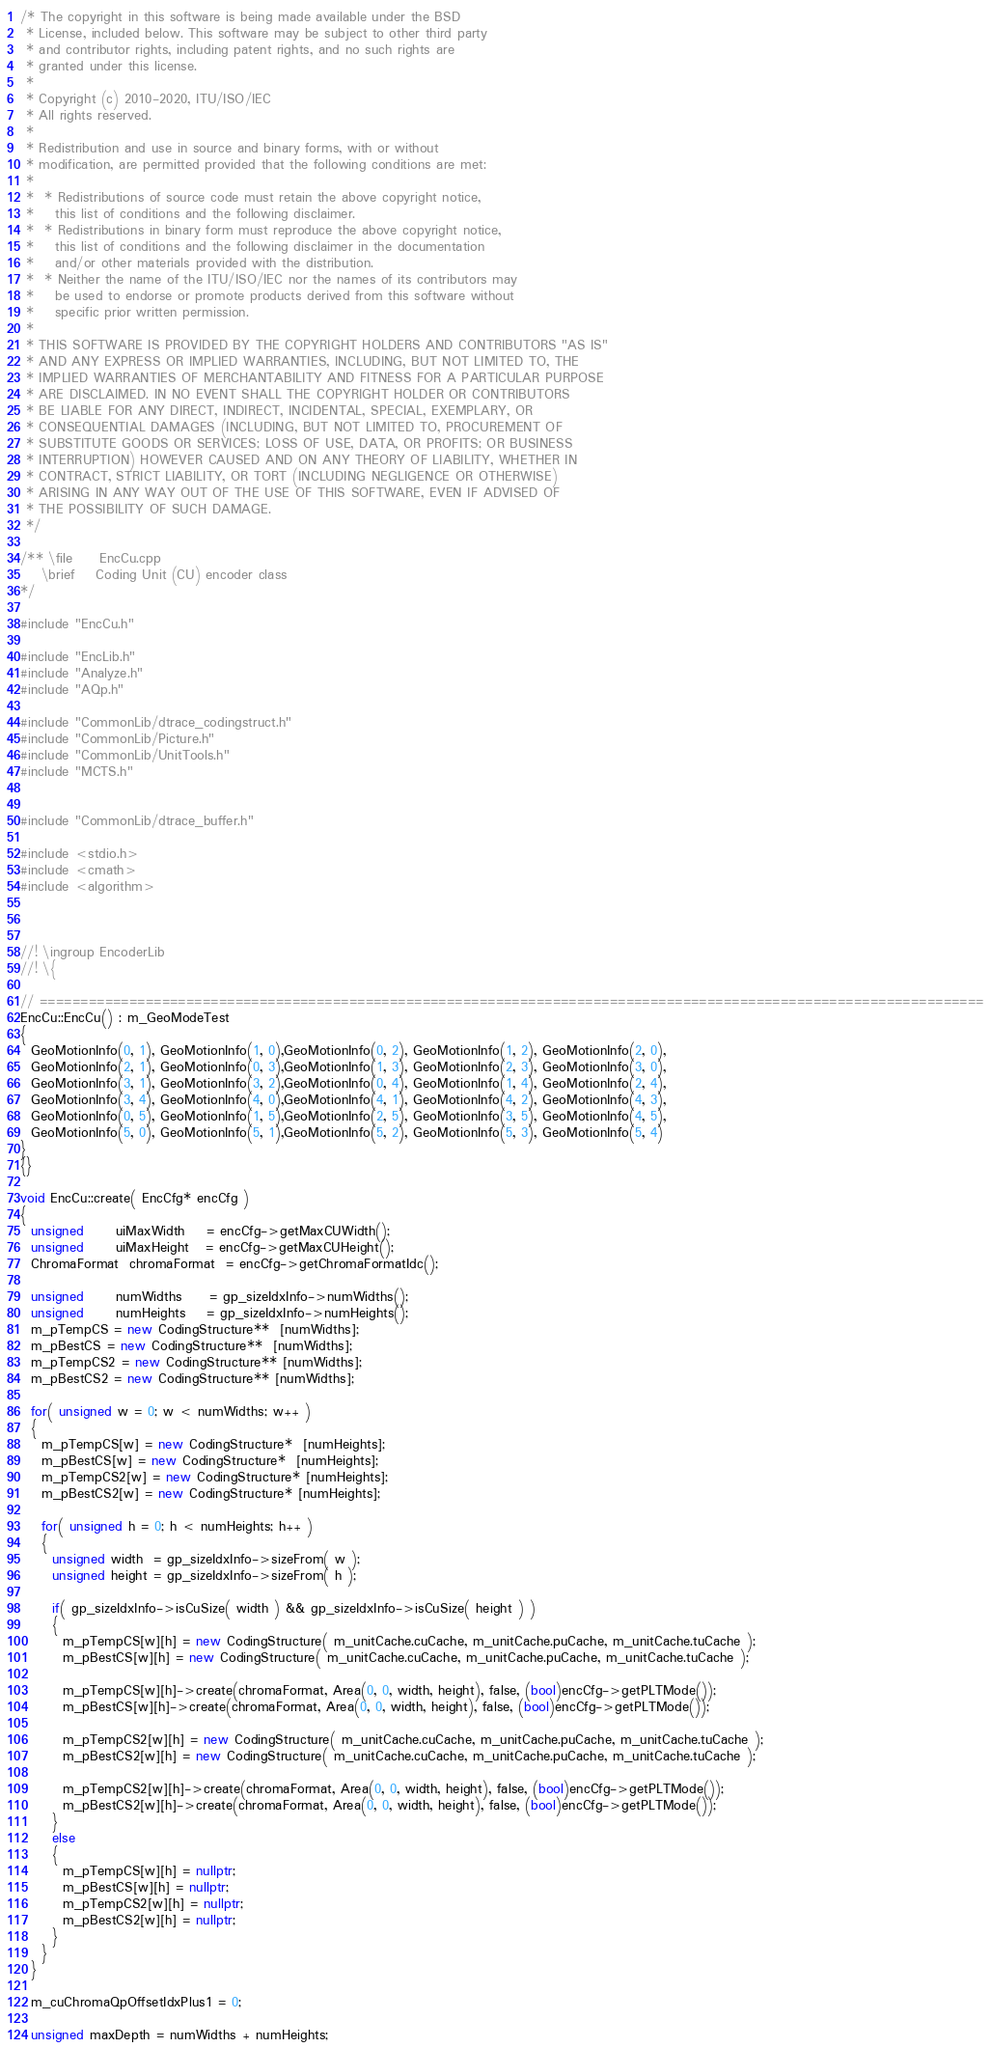<code> <loc_0><loc_0><loc_500><loc_500><_C++_>/* The copyright in this software is being made available under the BSD
 * License, included below. This software may be subject to other third party
 * and contributor rights, including patent rights, and no such rights are
 * granted under this license.
 *
 * Copyright (c) 2010-2020, ITU/ISO/IEC
 * All rights reserved.
 *
 * Redistribution and use in source and binary forms, with or without
 * modification, are permitted provided that the following conditions are met:
 *
 *  * Redistributions of source code must retain the above copyright notice,
 *    this list of conditions and the following disclaimer.
 *  * Redistributions in binary form must reproduce the above copyright notice,
 *    this list of conditions and the following disclaimer in the documentation
 *    and/or other materials provided with the distribution.
 *  * Neither the name of the ITU/ISO/IEC nor the names of its contributors may
 *    be used to endorse or promote products derived from this software without
 *    specific prior written permission.
 *
 * THIS SOFTWARE IS PROVIDED BY THE COPYRIGHT HOLDERS AND CONTRIBUTORS "AS IS"
 * AND ANY EXPRESS OR IMPLIED WARRANTIES, INCLUDING, BUT NOT LIMITED TO, THE
 * IMPLIED WARRANTIES OF MERCHANTABILITY AND FITNESS FOR A PARTICULAR PURPOSE
 * ARE DISCLAIMED. IN NO EVENT SHALL THE COPYRIGHT HOLDER OR CONTRIBUTORS
 * BE LIABLE FOR ANY DIRECT, INDIRECT, INCIDENTAL, SPECIAL, EXEMPLARY, OR
 * CONSEQUENTIAL DAMAGES (INCLUDING, BUT NOT LIMITED TO, PROCUREMENT OF
 * SUBSTITUTE GOODS OR SERVICES; LOSS OF USE, DATA, OR PROFITS; OR BUSINESS
 * INTERRUPTION) HOWEVER CAUSED AND ON ANY THEORY OF LIABILITY, WHETHER IN
 * CONTRACT, STRICT LIABILITY, OR TORT (INCLUDING NEGLIGENCE OR OTHERWISE)
 * ARISING IN ANY WAY OUT OF THE USE OF THIS SOFTWARE, EVEN IF ADVISED OF
 * THE POSSIBILITY OF SUCH DAMAGE.
 */

/** \file     EncCu.cpp
    \brief    Coding Unit (CU) encoder class
*/

#include "EncCu.h"

#include "EncLib.h"
#include "Analyze.h"
#include "AQp.h"

#include "CommonLib/dtrace_codingstruct.h"
#include "CommonLib/Picture.h"
#include "CommonLib/UnitTools.h"
#include "MCTS.h"


#include "CommonLib/dtrace_buffer.h"

#include <stdio.h>
#include <cmath>
#include <algorithm>



//! \ingroup EncoderLib
//! \{

// ====================================================================================================================
EncCu::EncCu() : m_GeoModeTest
{
  GeoMotionInfo(0, 1), GeoMotionInfo(1, 0),GeoMotionInfo(0, 2), GeoMotionInfo(1, 2), GeoMotionInfo(2, 0),
  GeoMotionInfo(2, 1), GeoMotionInfo(0, 3),GeoMotionInfo(1, 3), GeoMotionInfo(2, 3), GeoMotionInfo(3, 0),
  GeoMotionInfo(3, 1), GeoMotionInfo(3, 2),GeoMotionInfo(0, 4), GeoMotionInfo(1, 4), GeoMotionInfo(2, 4),
  GeoMotionInfo(3, 4), GeoMotionInfo(4, 0),GeoMotionInfo(4, 1), GeoMotionInfo(4, 2), GeoMotionInfo(4, 3),
  GeoMotionInfo(0, 5), GeoMotionInfo(1, 5),GeoMotionInfo(2, 5), GeoMotionInfo(3, 5), GeoMotionInfo(4, 5),
  GeoMotionInfo(5, 0), GeoMotionInfo(5, 1),GeoMotionInfo(5, 2), GeoMotionInfo(5, 3), GeoMotionInfo(5, 4)
}
{}

void EncCu::create( EncCfg* encCfg )
{
  unsigned      uiMaxWidth    = encCfg->getMaxCUWidth();
  unsigned      uiMaxHeight   = encCfg->getMaxCUHeight();
  ChromaFormat  chromaFormat  = encCfg->getChromaFormatIdc();

  unsigned      numWidths     = gp_sizeIdxInfo->numWidths();
  unsigned      numHeights    = gp_sizeIdxInfo->numHeights();
  m_pTempCS = new CodingStructure**  [numWidths];
  m_pBestCS = new CodingStructure**  [numWidths];
  m_pTempCS2 = new CodingStructure** [numWidths];
  m_pBestCS2 = new CodingStructure** [numWidths];

  for( unsigned w = 0; w < numWidths; w++ )
  {
    m_pTempCS[w] = new CodingStructure*  [numHeights];
    m_pBestCS[w] = new CodingStructure*  [numHeights];
    m_pTempCS2[w] = new CodingStructure* [numHeights];
    m_pBestCS2[w] = new CodingStructure* [numHeights];

    for( unsigned h = 0; h < numHeights; h++ )
    {
      unsigned width  = gp_sizeIdxInfo->sizeFrom( w );
      unsigned height = gp_sizeIdxInfo->sizeFrom( h );

      if( gp_sizeIdxInfo->isCuSize( width ) && gp_sizeIdxInfo->isCuSize( height ) )
      {
        m_pTempCS[w][h] = new CodingStructure( m_unitCache.cuCache, m_unitCache.puCache, m_unitCache.tuCache );
        m_pBestCS[w][h] = new CodingStructure( m_unitCache.cuCache, m_unitCache.puCache, m_unitCache.tuCache );

        m_pTempCS[w][h]->create(chromaFormat, Area(0, 0, width, height), false, (bool)encCfg->getPLTMode());
        m_pBestCS[w][h]->create(chromaFormat, Area(0, 0, width, height), false, (bool)encCfg->getPLTMode());

        m_pTempCS2[w][h] = new CodingStructure( m_unitCache.cuCache, m_unitCache.puCache, m_unitCache.tuCache );
        m_pBestCS2[w][h] = new CodingStructure( m_unitCache.cuCache, m_unitCache.puCache, m_unitCache.tuCache );

        m_pTempCS2[w][h]->create(chromaFormat, Area(0, 0, width, height), false, (bool)encCfg->getPLTMode());
        m_pBestCS2[w][h]->create(chromaFormat, Area(0, 0, width, height), false, (bool)encCfg->getPLTMode());
      }
      else
      {
        m_pTempCS[w][h] = nullptr;
        m_pBestCS[w][h] = nullptr;
        m_pTempCS2[w][h] = nullptr;
        m_pBestCS2[w][h] = nullptr;
      }
    }
  }

  m_cuChromaQpOffsetIdxPlus1 = 0;

  unsigned maxDepth = numWidths + numHeights;
</code> 